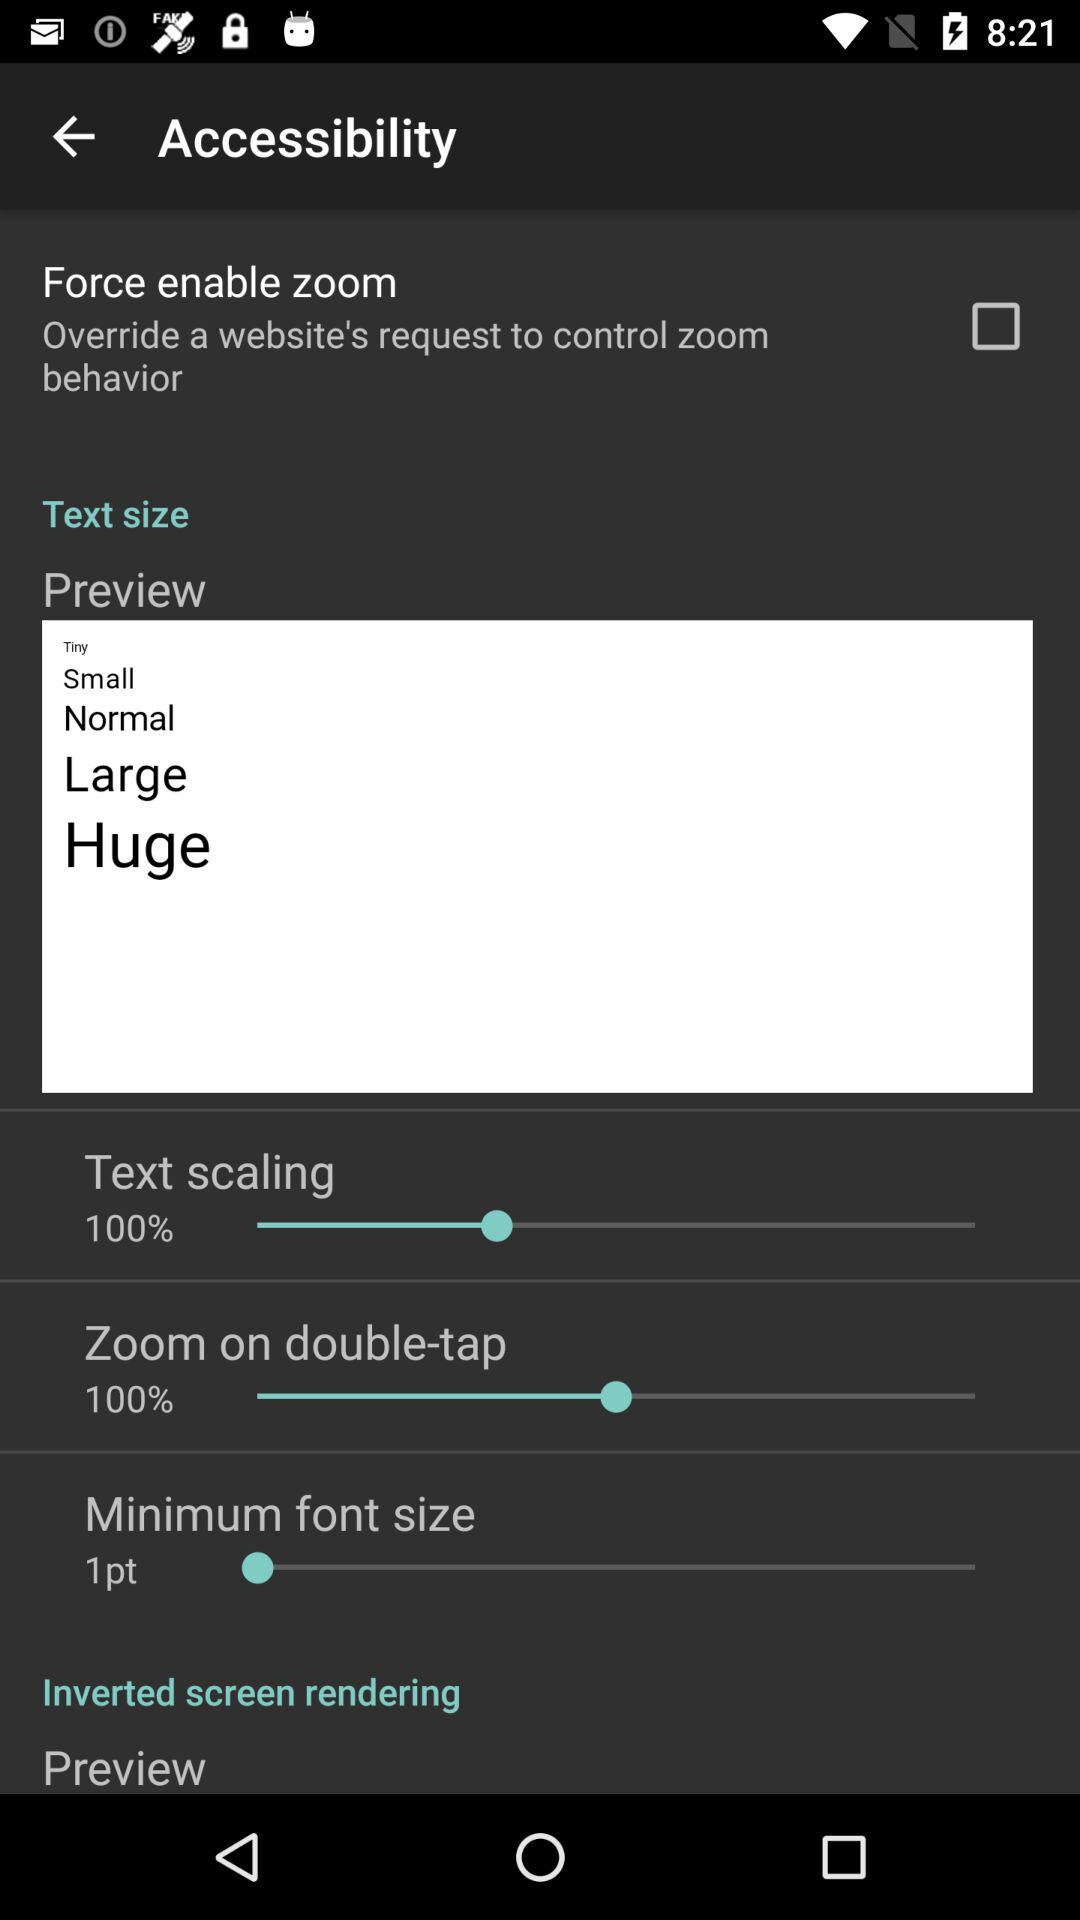How many more items are there in the text size section than the inverted screen rendering section?
Answer the question using a single word or phrase. 4 